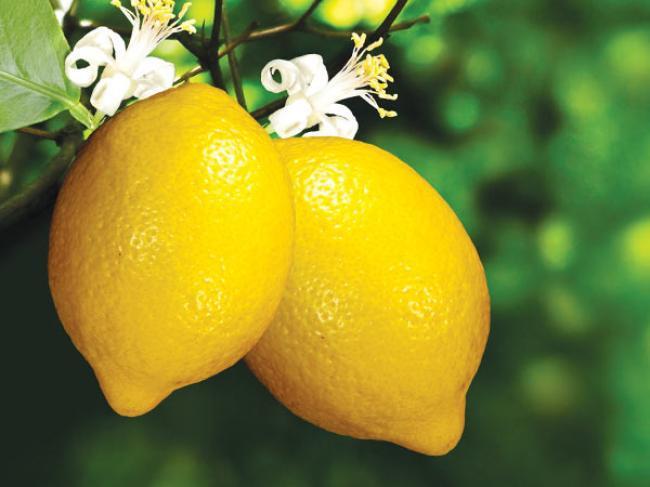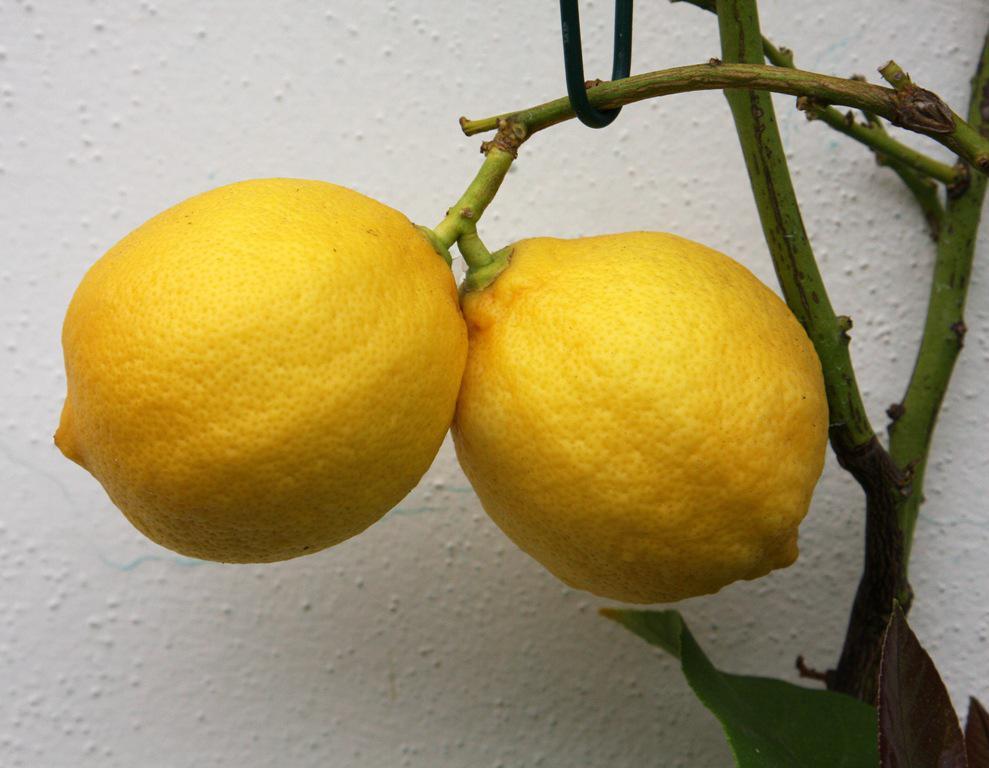The first image is the image on the left, the second image is the image on the right. For the images displayed, is the sentence "Each image contains exactly two whole lemons, and the lefthand image shows lemons joined with a piece of branch and leaves intact, sitting on a surface." factually correct? Answer yes or no. No. 